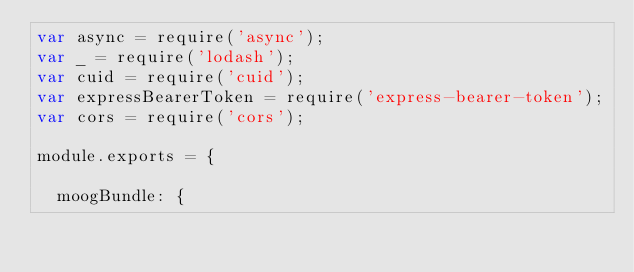Convert code to text. <code><loc_0><loc_0><loc_500><loc_500><_JavaScript_>var async = require('async');
var _ = require('lodash');
var cuid = require('cuid');
var expressBearerToken = require('express-bearer-token');
var cors = require('cors');

module.exports = {

  moogBundle: {</code> 